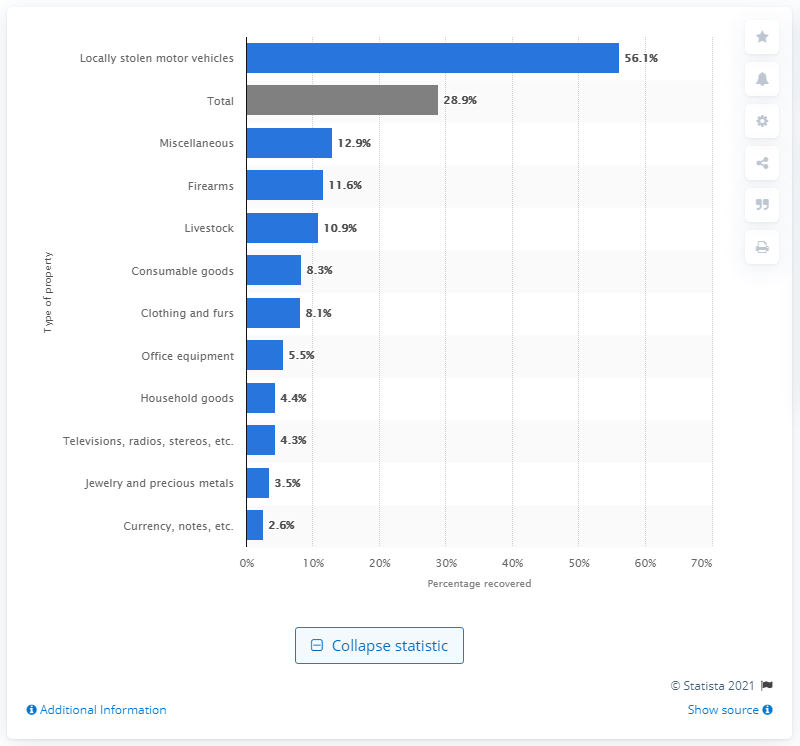Point out several critical features in this image. In 2019, 56.1% of stolen motor vehicles were recovered. 